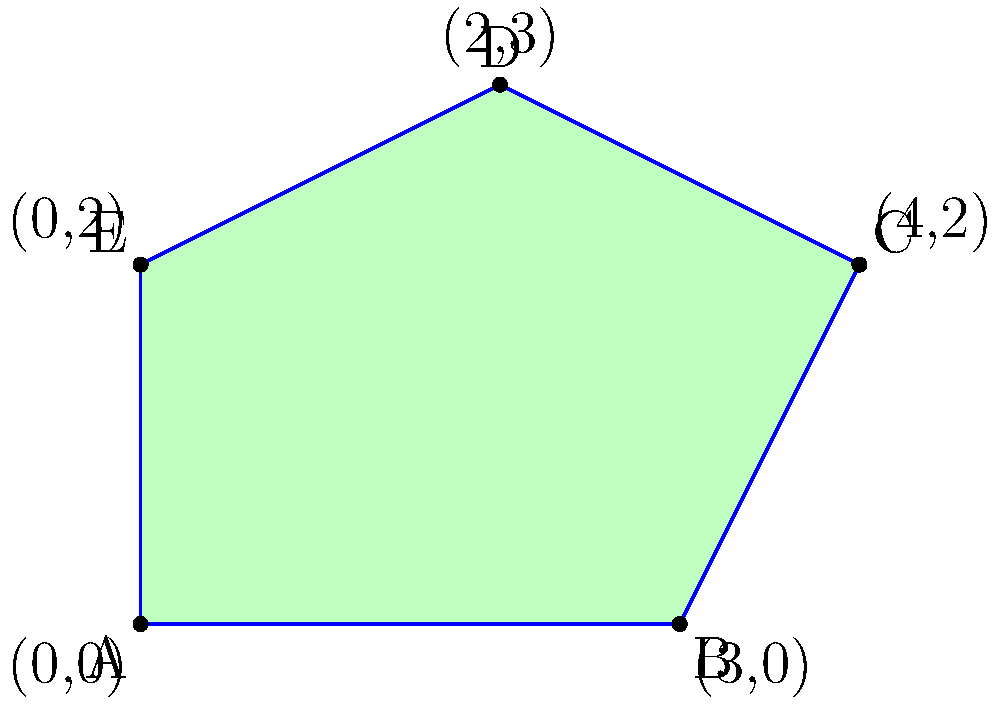In your fantasy world map, there's an irregularly shaped region represented by the polygon ABCDE. Given the coordinates of its vertices: A(0,0), B(3,0), C(4,2), D(2,3), and E(0,2), calculate the area of this region in square units. To calculate the area of this irregular polygon, we can use the Shoelace formula (also known as the surveyor's formula). The steps are as follows:

1) The Shoelace formula for a polygon with vertices $(x_1, y_1), (x_2, y_2), ..., (x_n, y_n)$ is:

   $$Area = \frac{1}{2}|(x_1y_2 + x_2y_3 + ... + x_ny_1) - (y_1x_2 + y_2x_3 + ... + y_nx_1)|$$

2) Let's arrange our vertices in order:
   A(0,0), B(3,0), C(4,2), D(2,3), E(0,2)

3) Now, let's apply the formula:

   $$Area = \frac{1}{2}|(0\cdot0 + 3\cdot2 + 4\cdot3 + 2\cdot2 + 0\cdot0) - (0\cdot3 + 0\cdot4 + 2\cdot2 + 3\cdot0 + 2\cdot0)|$$

4) Simplify:
   $$Area = \frac{1}{2}|(0 + 6 + 12 + 4 + 0) - (0 + 0 + 4 + 0 + 0)|$$
   $$Area = \frac{1}{2}|22 - 4|$$
   $$Area = \frac{1}{2}|18|$$
   $$Area = \frac{1}{2}(18)$$
   $$Area = 9$$

Therefore, the area of the irregular region is 9 square units.
Answer: 9 square units 